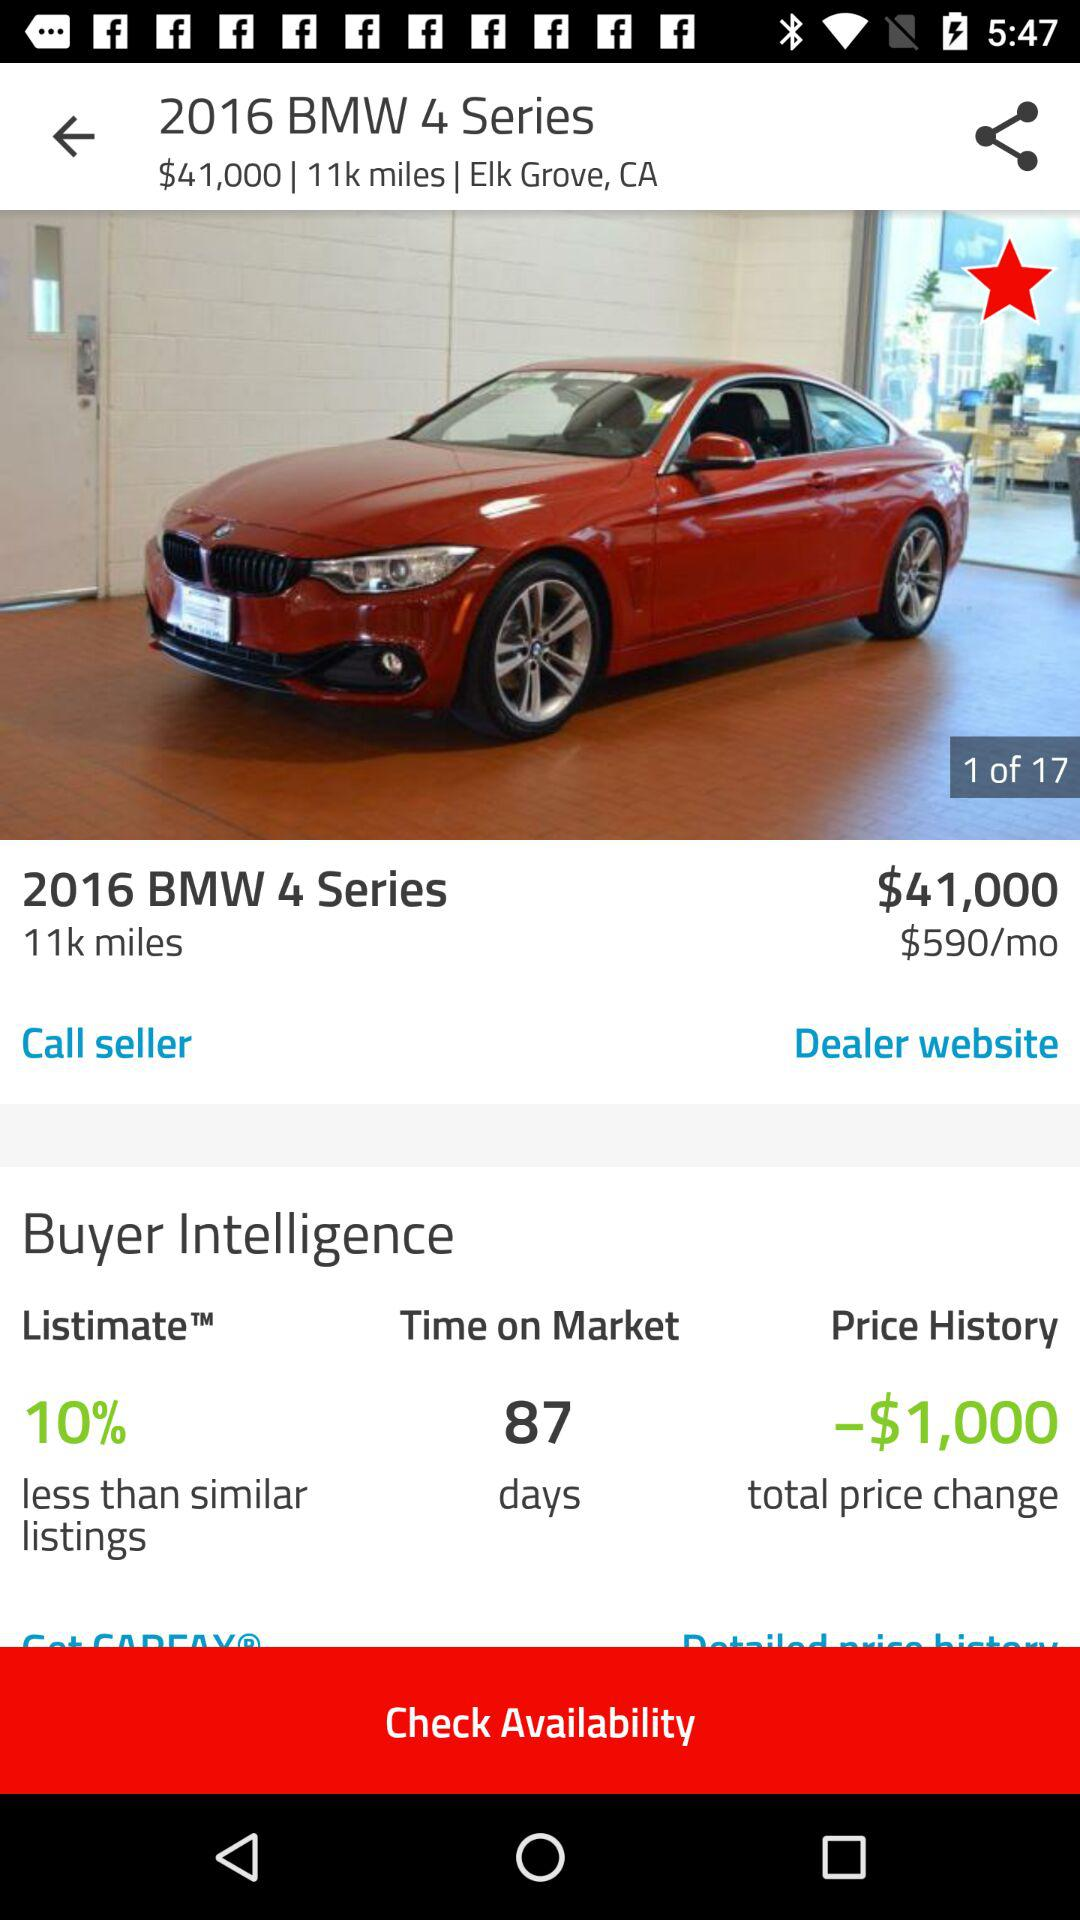What is the "Time on Market"? The "Time on Market" is 87 days. 